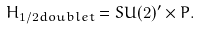<formula> <loc_0><loc_0><loc_500><loc_500>H _ { 1 / 2 d o u b l e t } = S U ( 2 ) ^ { \prime } \times P .</formula> 